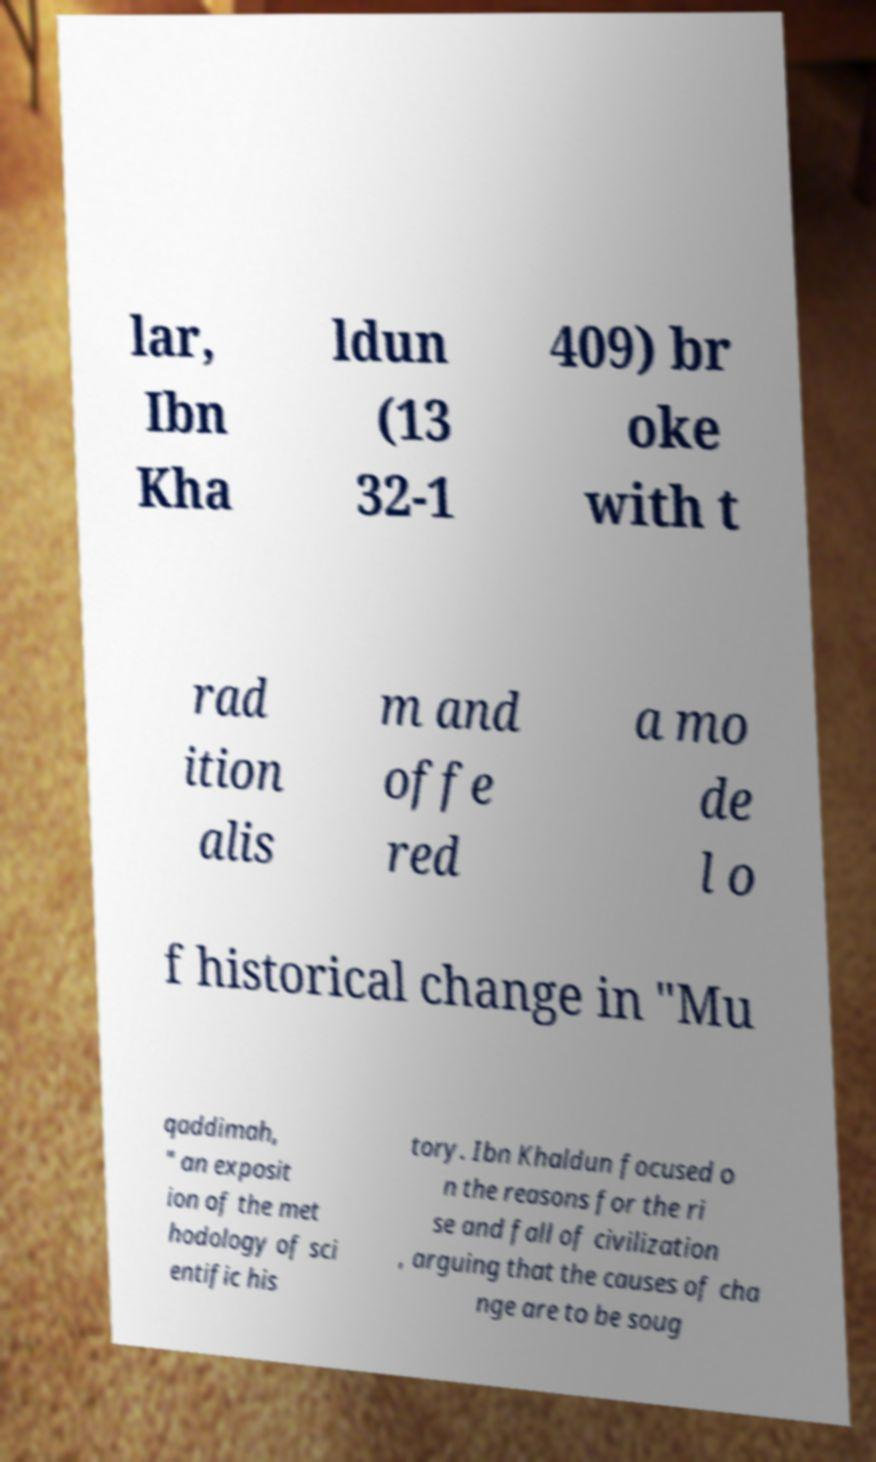Can you read and provide the text displayed in the image?This photo seems to have some interesting text. Can you extract and type it out for me? lar, Ibn Kha ldun (13 32-1 409) br oke with t rad ition alis m and offe red a mo de l o f historical change in "Mu qaddimah, " an exposit ion of the met hodology of sci entific his tory. Ibn Khaldun focused o n the reasons for the ri se and fall of civilization , arguing that the causes of cha nge are to be soug 